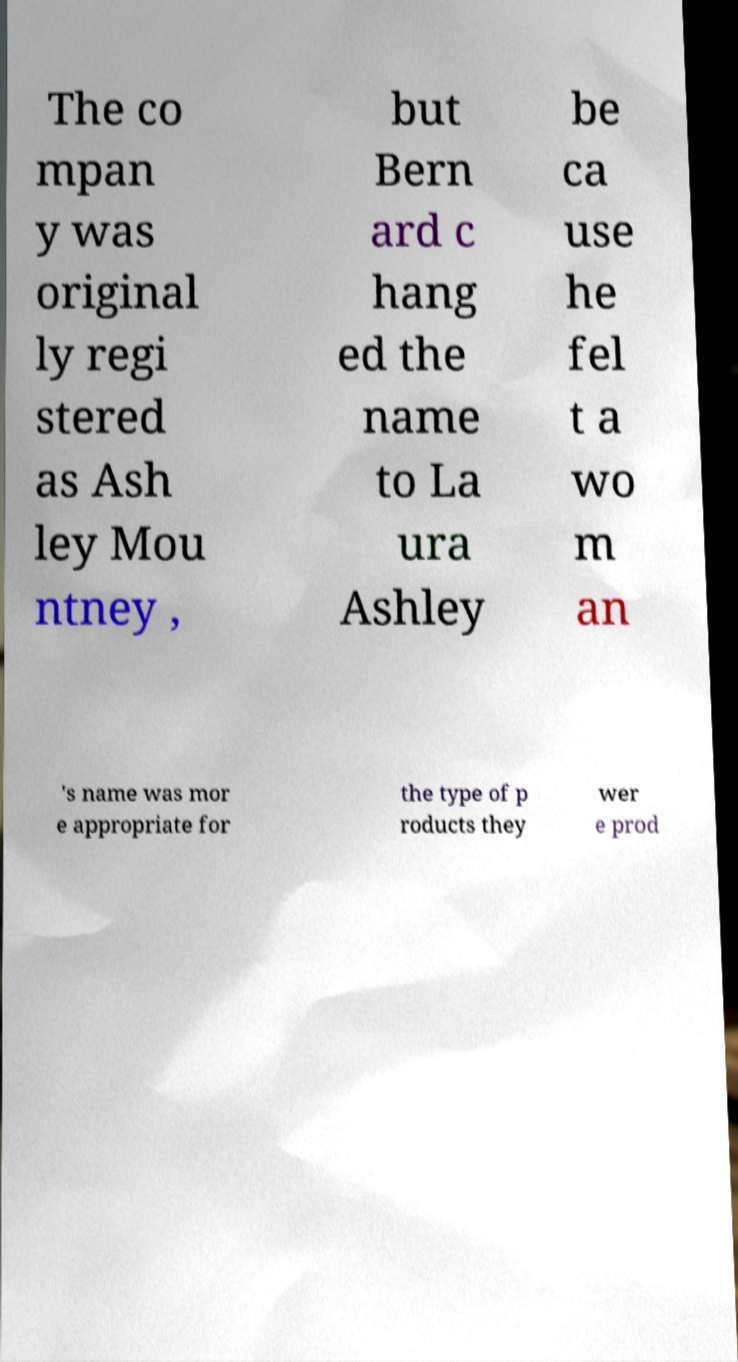What messages or text are displayed in this image? I need them in a readable, typed format. The image contains text that appears to discuss the renaming of a company. It reads: 'The company was originally registered as Ashley Mountney, but Bernard changed the name to Laura Ashley because he felt a woman's name was more appropriate for the type of products they were producing.' 